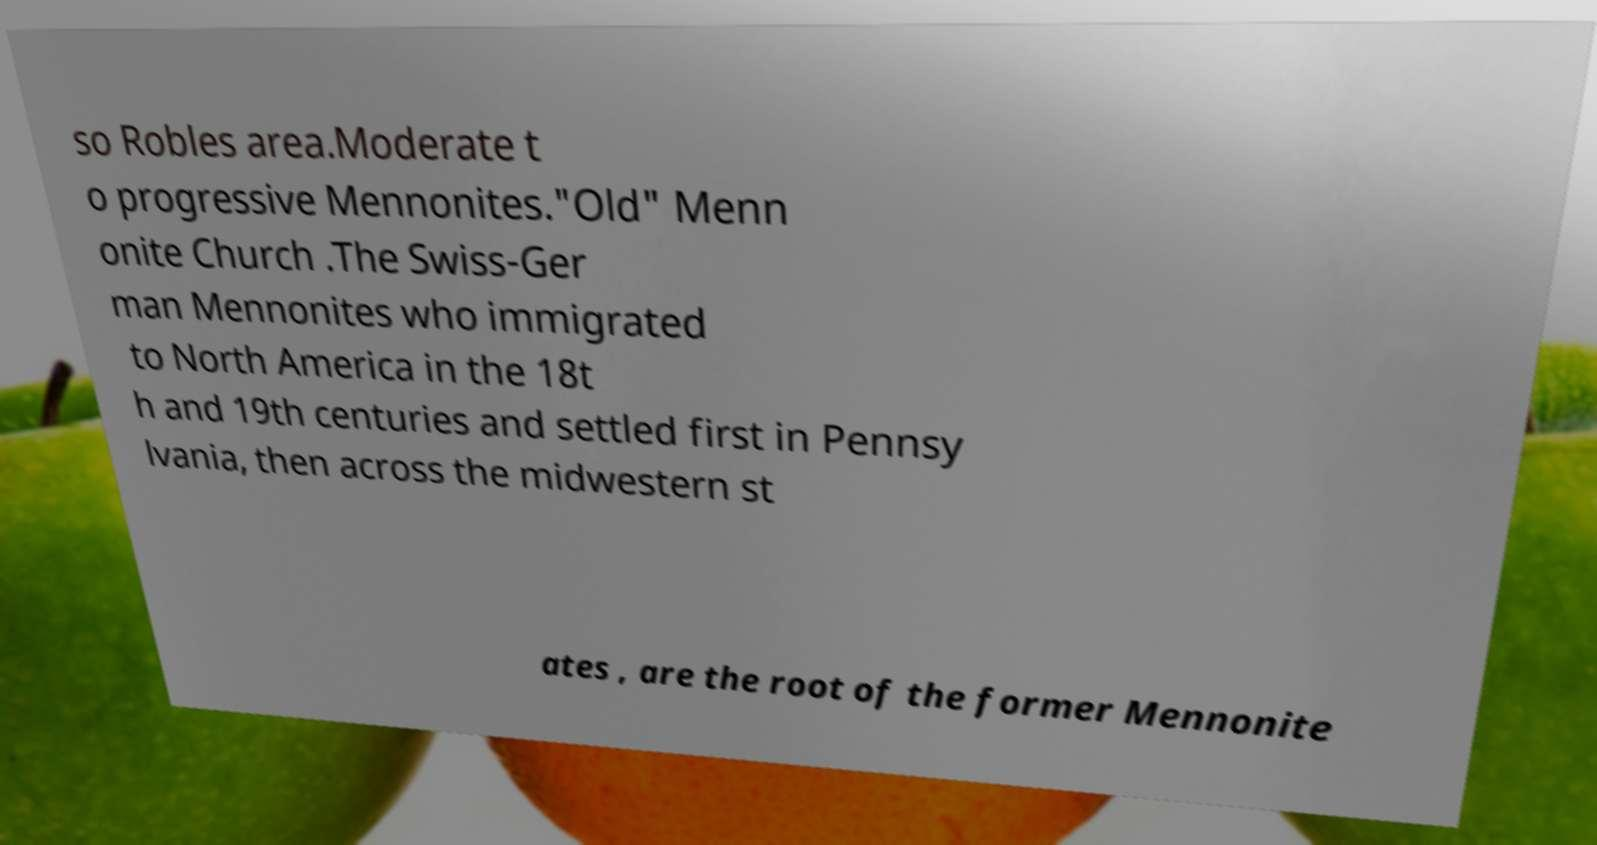Can you read and provide the text displayed in the image?This photo seems to have some interesting text. Can you extract and type it out for me? so Robles area.Moderate t o progressive Mennonites."Old" Menn onite Church .The Swiss-Ger man Mennonites who immigrated to North America in the 18t h and 19th centuries and settled first in Pennsy lvania, then across the midwestern st ates , are the root of the former Mennonite 